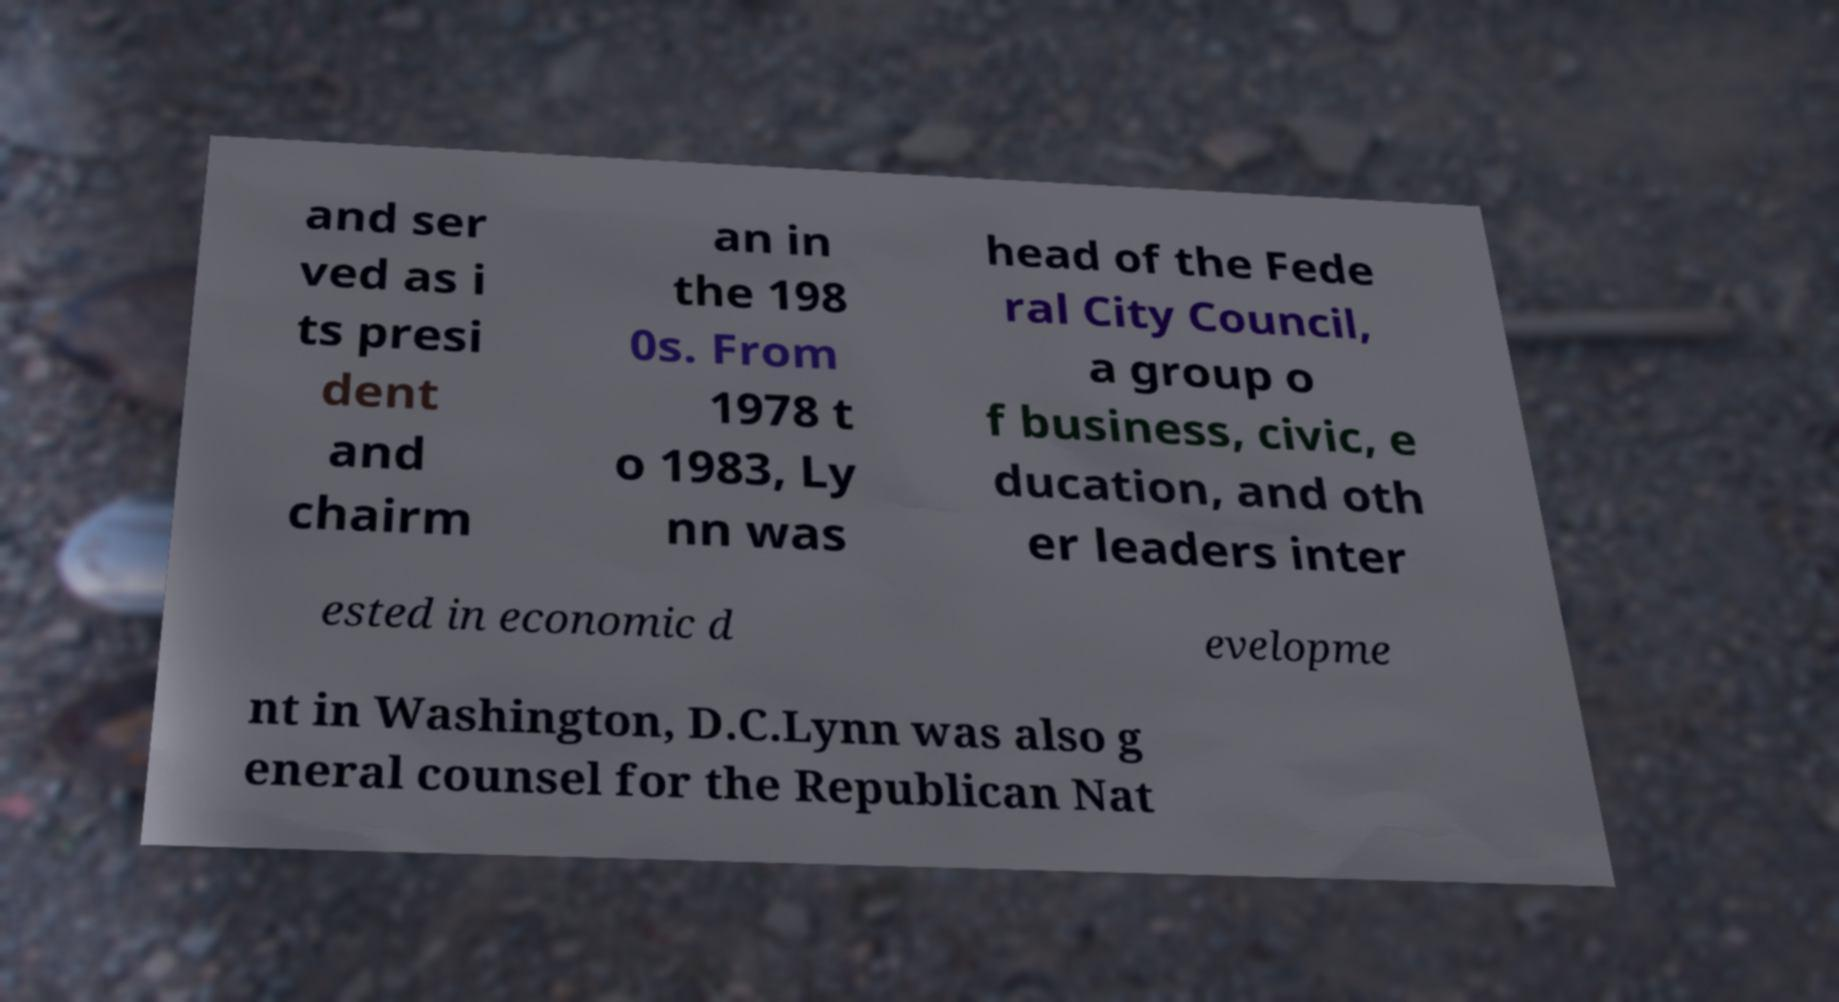What messages or text are displayed in this image? I need them in a readable, typed format. and ser ved as i ts presi dent and chairm an in the 198 0s. From 1978 t o 1983, Ly nn was head of the Fede ral City Council, a group o f business, civic, e ducation, and oth er leaders inter ested in economic d evelopme nt in Washington, D.C.Lynn was also g eneral counsel for the Republican Nat 